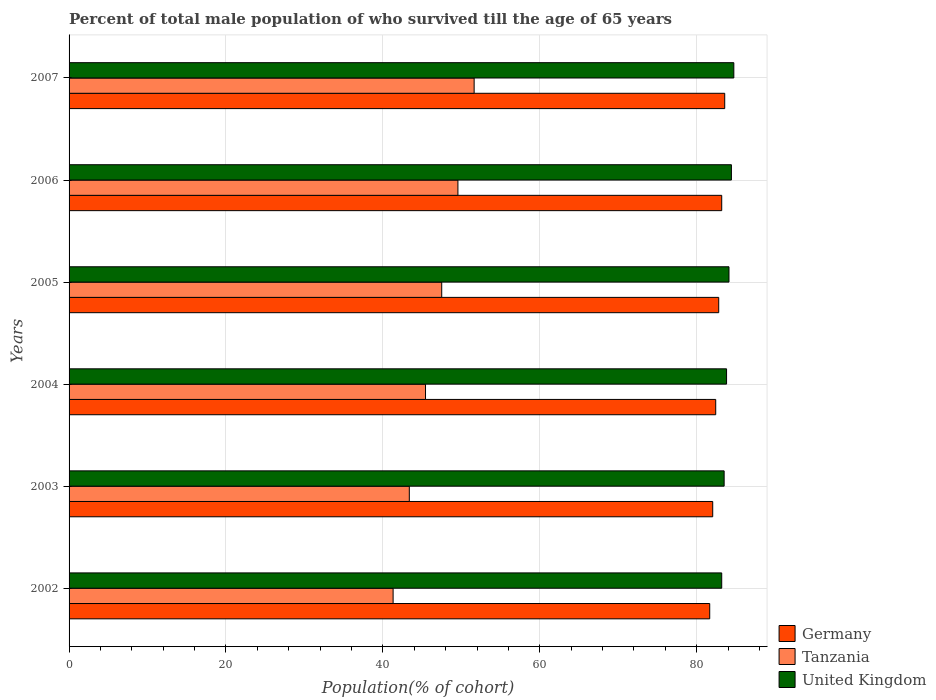Are the number of bars per tick equal to the number of legend labels?
Offer a very short reply. Yes. Are the number of bars on each tick of the Y-axis equal?
Make the answer very short. Yes. How many bars are there on the 1st tick from the top?
Provide a succinct answer. 3. In how many cases, is the number of bars for a given year not equal to the number of legend labels?
Ensure brevity in your answer.  0. What is the percentage of total male population who survived till the age of 65 years in Tanzania in 2006?
Give a very brief answer. 49.56. Across all years, what is the maximum percentage of total male population who survived till the age of 65 years in Germany?
Give a very brief answer. 83.57. Across all years, what is the minimum percentage of total male population who survived till the age of 65 years in Tanzania?
Offer a terse response. 41.3. In which year was the percentage of total male population who survived till the age of 65 years in Tanzania minimum?
Keep it short and to the point. 2002. What is the total percentage of total male population who survived till the age of 65 years in Tanzania in the graph?
Provide a short and direct response. 278.79. What is the difference between the percentage of total male population who survived till the age of 65 years in Germany in 2002 and that in 2006?
Your answer should be compact. -1.53. What is the difference between the percentage of total male population who survived till the age of 65 years in Germany in 2006 and the percentage of total male population who survived till the age of 65 years in United Kingdom in 2003?
Your answer should be very brief. -0.31. What is the average percentage of total male population who survived till the age of 65 years in Germany per year?
Make the answer very short. 82.61. In the year 2007, what is the difference between the percentage of total male population who survived till the age of 65 years in Tanzania and percentage of total male population who survived till the age of 65 years in United Kingdom?
Provide a succinct answer. -33.1. What is the ratio of the percentage of total male population who survived till the age of 65 years in Germany in 2004 to that in 2006?
Provide a short and direct response. 0.99. Is the percentage of total male population who survived till the age of 65 years in Germany in 2004 less than that in 2007?
Provide a succinct answer. Yes. What is the difference between the highest and the second highest percentage of total male population who survived till the age of 65 years in Germany?
Your answer should be very brief. 0.38. What is the difference between the highest and the lowest percentage of total male population who survived till the age of 65 years in Tanzania?
Ensure brevity in your answer.  10.33. In how many years, is the percentage of total male population who survived till the age of 65 years in Germany greater than the average percentage of total male population who survived till the age of 65 years in Germany taken over all years?
Keep it short and to the point. 3. Is the sum of the percentage of total male population who survived till the age of 65 years in United Kingdom in 2004 and 2007 greater than the maximum percentage of total male population who survived till the age of 65 years in Germany across all years?
Keep it short and to the point. Yes. What does the 2nd bar from the bottom in 2005 represents?
Your response must be concise. Tanzania. Is it the case that in every year, the sum of the percentage of total male population who survived till the age of 65 years in United Kingdom and percentage of total male population who survived till the age of 65 years in Germany is greater than the percentage of total male population who survived till the age of 65 years in Tanzania?
Ensure brevity in your answer.  Yes. Are all the bars in the graph horizontal?
Offer a terse response. Yes. What is the difference between two consecutive major ticks on the X-axis?
Offer a very short reply. 20. Does the graph contain grids?
Your answer should be compact. Yes. Where does the legend appear in the graph?
Offer a terse response. Bottom right. How many legend labels are there?
Offer a terse response. 3. What is the title of the graph?
Make the answer very short. Percent of total male population of who survived till the age of 65 years. Does "Suriname" appear as one of the legend labels in the graph?
Offer a terse response. No. What is the label or title of the X-axis?
Provide a short and direct response. Population(% of cohort). What is the label or title of the Y-axis?
Give a very brief answer. Years. What is the Population(% of cohort) in Germany in 2002?
Your response must be concise. 81.65. What is the Population(% of cohort) in Tanzania in 2002?
Your answer should be compact. 41.3. What is the Population(% of cohort) of United Kingdom in 2002?
Provide a succinct answer. 83.18. What is the Population(% of cohort) in Germany in 2003?
Provide a short and direct response. 82.04. What is the Population(% of cohort) of Tanzania in 2003?
Give a very brief answer. 43.37. What is the Population(% of cohort) of United Kingdom in 2003?
Keep it short and to the point. 83.49. What is the Population(% of cohort) of Germany in 2004?
Provide a succinct answer. 82.42. What is the Population(% of cohort) of Tanzania in 2004?
Provide a succinct answer. 45.43. What is the Population(% of cohort) of United Kingdom in 2004?
Offer a very short reply. 83.8. What is the Population(% of cohort) of Germany in 2005?
Your answer should be compact. 82.8. What is the Population(% of cohort) in Tanzania in 2005?
Offer a very short reply. 47.5. What is the Population(% of cohort) in United Kingdom in 2005?
Your answer should be compact. 84.11. What is the Population(% of cohort) of Germany in 2006?
Your response must be concise. 83.19. What is the Population(% of cohort) in Tanzania in 2006?
Ensure brevity in your answer.  49.56. What is the Population(% of cohort) of United Kingdom in 2006?
Your answer should be very brief. 84.42. What is the Population(% of cohort) of Germany in 2007?
Your answer should be very brief. 83.57. What is the Population(% of cohort) of Tanzania in 2007?
Provide a short and direct response. 51.63. What is the Population(% of cohort) of United Kingdom in 2007?
Your answer should be very brief. 84.73. Across all years, what is the maximum Population(% of cohort) of Germany?
Provide a succinct answer. 83.57. Across all years, what is the maximum Population(% of cohort) in Tanzania?
Provide a short and direct response. 51.63. Across all years, what is the maximum Population(% of cohort) in United Kingdom?
Your answer should be compact. 84.73. Across all years, what is the minimum Population(% of cohort) in Germany?
Ensure brevity in your answer.  81.65. Across all years, what is the minimum Population(% of cohort) in Tanzania?
Offer a terse response. 41.3. Across all years, what is the minimum Population(% of cohort) in United Kingdom?
Offer a very short reply. 83.18. What is the total Population(% of cohort) in Germany in the graph?
Your response must be concise. 495.67. What is the total Population(% of cohort) of Tanzania in the graph?
Your response must be concise. 278.79. What is the total Population(% of cohort) in United Kingdom in the graph?
Offer a terse response. 503.74. What is the difference between the Population(% of cohort) of Germany in 2002 and that in 2003?
Offer a very short reply. -0.38. What is the difference between the Population(% of cohort) of Tanzania in 2002 and that in 2003?
Provide a succinct answer. -2.07. What is the difference between the Population(% of cohort) of United Kingdom in 2002 and that in 2003?
Provide a succinct answer. -0.31. What is the difference between the Population(% of cohort) in Germany in 2002 and that in 2004?
Offer a very short reply. -0.77. What is the difference between the Population(% of cohort) of Tanzania in 2002 and that in 2004?
Make the answer very short. -4.13. What is the difference between the Population(% of cohort) in United Kingdom in 2002 and that in 2004?
Keep it short and to the point. -0.62. What is the difference between the Population(% of cohort) of Germany in 2002 and that in 2005?
Your response must be concise. -1.15. What is the difference between the Population(% of cohort) in Tanzania in 2002 and that in 2005?
Make the answer very short. -6.2. What is the difference between the Population(% of cohort) in United Kingdom in 2002 and that in 2005?
Your response must be concise. -0.93. What is the difference between the Population(% of cohort) in Germany in 2002 and that in 2006?
Offer a very short reply. -1.53. What is the difference between the Population(% of cohort) of Tanzania in 2002 and that in 2006?
Keep it short and to the point. -8.26. What is the difference between the Population(% of cohort) in United Kingdom in 2002 and that in 2006?
Your answer should be very brief. -1.24. What is the difference between the Population(% of cohort) of Germany in 2002 and that in 2007?
Ensure brevity in your answer.  -1.91. What is the difference between the Population(% of cohort) of Tanzania in 2002 and that in 2007?
Ensure brevity in your answer.  -10.33. What is the difference between the Population(% of cohort) in United Kingdom in 2002 and that in 2007?
Your answer should be compact. -1.54. What is the difference between the Population(% of cohort) of Germany in 2003 and that in 2004?
Offer a very short reply. -0.38. What is the difference between the Population(% of cohort) in Tanzania in 2003 and that in 2004?
Offer a very short reply. -2.07. What is the difference between the Population(% of cohort) of United Kingdom in 2003 and that in 2004?
Ensure brevity in your answer.  -0.31. What is the difference between the Population(% of cohort) of Germany in 2003 and that in 2005?
Your answer should be compact. -0.77. What is the difference between the Population(% of cohort) in Tanzania in 2003 and that in 2005?
Make the answer very short. -4.13. What is the difference between the Population(% of cohort) in United Kingdom in 2003 and that in 2005?
Your response must be concise. -0.62. What is the difference between the Population(% of cohort) of Germany in 2003 and that in 2006?
Give a very brief answer. -1.15. What is the difference between the Population(% of cohort) of Tanzania in 2003 and that in 2006?
Provide a succinct answer. -6.2. What is the difference between the Population(% of cohort) in United Kingdom in 2003 and that in 2006?
Keep it short and to the point. -0.93. What is the difference between the Population(% of cohort) in Germany in 2003 and that in 2007?
Your response must be concise. -1.53. What is the difference between the Population(% of cohort) of Tanzania in 2003 and that in 2007?
Offer a very short reply. -8.26. What is the difference between the Population(% of cohort) of United Kingdom in 2003 and that in 2007?
Provide a succinct answer. -1.24. What is the difference between the Population(% of cohort) in Germany in 2004 and that in 2005?
Your answer should be compact. -0.38. What is the difference between the Population(% of cohort) of Tanzania in 2004 and that in 2005?
Ensure brevity in your answer.  -2.07. What is the difference between the Population(% of cohort) in United Kingdom in 2004 and that in 2005?
Make the answer very short. -0.31. What is the difference between the Population(% of cohort) of Germany in 2004 and that in 2006?
Your answer should be very brief. -0.77. What is the difference between the Population(% of cohort) in Tanzania in 2004 and that in 2006?
Give a very brief answer. -4.13. What is the difference between the Population(% of cohort) of United Kingdom in 2004 and that in 2006?
Your answer should be compact. -0.62. What is the difference between the Population(% of cohort) of Germany in 2004 and that in 2007?
Make the answer very short. -1.15. What is the difference between the Population(% of cohort) in Tanzania in 2004 and that in 2007?
Make the answer very short. -6.2. What is the difference between the Population(% of cohort) of United Kingdom in 2004 and that in 2007?
Offer a very short reply. -0.93. What is the difference between the Population(% of cohort) of Germany in 2005 and that in 2006?
Provide a succinct answer. -0.38. What is the difference between the Population(% of cohort) of Tanzania in 2005 and that in 2006?
Your answer should be very brief. -2.07. What is the difference between the Population(% of cohort) of United Kingdom in 2005 and that in 2006?
Offer a terse response. -0.31. What is the difference between the Population(% of cohort) in Germany in 2005 and that in 2007?
Your response must be concise. -0.77. What is the difference between the Population(% of cohort) in Tanzania in 2005 and that in 2007?
Ensure brevity in your answer.  -4.13. What is the difference between the Population(% of cohort) in United Kingdom in 2005 and that in 2007?
Offer a terse response. -0.62. What is the difference between the Population(% of cohort) in Germany in 2006 and that in 2007?
Ensure brevity in your answer.  -0.38. What is the difference between the Population(% of cohort) of Tanzania in 2006 and that in 2007?
Ensure brevity in your answer.  -2.07. What is the difference between the Population(% of cohort) in United Kingdom in 2006 and that in 2007?
Your answer should be very brief. -0.31. What is the difference between the Population(% of cohort) of Germany in 2002 and the Population(% of cohort) of Tanzania in 2003?
Keep it short and to the point. 38.29. What is the difference between the Population(% of cohort) of Germany in 2002 and the Population(% of cohort) of United Kingdom in 2003?
Your response must be concise. -1.84. What is the difference between the Population(% of cohort) of Tanzania in 2002 and the Population(% of cohort) of United Kingdom in 2003?
Provide a succinct answer. -42.19. What is the difference between the Population(% of cohort) in Germany in 2002 and the Population(% of cohort) in Tanzania in 2004?
Make the answer very short. 36.22. What is the difference between the Population(% of cohort) in Germany in 2002 and the Population(% of cohort) in United Kingdom in 2004?
Offer a very short reply. -2.15. What is the difference between the Population(% of cohort) of Tanzania in 2002 and the Population(% of cohort) of United Kingdom in 2004?
Make the answer very short. -42.5. What is the difference between the Population(% of cohort) of Germany in 2002 and the Population(% of cohort) of Tanzania in 2005?
Keep it short and to the point. 34.16. What is the difference between the Population(% of cohort) in Germany in 2002 and the Population(% of cohort) in United Kingdom in 2005?
Your answer should be compact. -2.46. What is the difference between the Population(% of cohort) of Tanzania in 2002 and the Population(% of cohort) of United Kingdom in 2005?
Give a very brief answer. -42.81. What is the difference between the Population(% of cohort) in Germany in 2002 and the Population(% of cohort) in Tanzania in 2006?
Your answer should be compact. 32.09. What is the difference between the Population(% of cohort) of Germany in 2002 and the Population(% of cohort) of United Kingdom in 2006?
Provide a succinct answer. -2.77. What is the difference between the Population(% of cohort) of Tanzania in 2002 and the Population(% of cohort) of United Kingdom in 2006?
Make the answer very short. -43.12. What is the difference between the Population(% of cohort) in Germany in 2002 and the Population(% of cohort) in Tanzania in 2007?
Make the answer very short. 30.03. What is the difference between the Population(% of cohort) in Germany in 2002 and the Population(% of cohort) in United Kingdom in 2007?
Provide a short and direct response. -3.07. What is the difference between the Population(% of cohort) in Tanzania in 2002 and the Population(% of cohort) in United Kingdom in 2007?
Your response must be concise. -43.43. What is the difference between the Population(% of cohort) of Germany in 2003 and the Population(% of cohort) of Tanzania in 2004?
Ensure brevity in your answer.  36.61. What is the difference between the Population(% of cohort) in Germany in 2003 and the Population(% of cohort) in United Kingdom in 2004?
Provide a short and direct response. -1.76. What is the difference between the Population(% of cohort) in Tanzania in 2003 and the Population(% of cohort) in United Kingdom in 2004?
Your answer should be very brief. -40.44. What is the difference between the Population(% of cohort) in Germany in 2003 and the Population(% of cohort) in Tanzania in 2005?
Give a very brief answer. 34.54. What is the difference between the Population(% of cohort) of Germany in 2003 and the Population(% of cohort) of United Kingdom in 2005?
Make the answer very short. -2.07. What is the difference between the Population(% of cohort) in Tanzania in 2003 and the Population(% of cohort) in United Kingdom in 2005?
Offer a very short reply. -40.74. What is the difference between the Population(% of cohort) in Germany in 2003 and the Population(% of cohort) in Tanzania in 2006?
Your answer should be compact. 32.47. What is the difference between the Population(% of cohort) in Germany in 2003 and the Population(% of cohort) in United Kingdom in 2006?
Keep it short and to the point. -2.38. What is the difference between the Population(% of cohort) in Tanzania in 2003 and the Population(% of cohort) in United Kingdom in 2006?
Offer a very short reply. -41.05. What is the difference between the Population(% of cohort) of Germany in 2003 and the Population(% of cohort) of Tanzania in 2007?
Offer a terse response. 30.41. What is the difference between the Population(% of cohort) of Germany in 2003 and the Population(% of cohort) of United Kingdom in 2007?
Your response must be concise. -2.69. What is the difference between the Population(% of cohort) in Tanzania in 2003 and the Population(% of cohort) in United Kingdom in 2007?
Make the answer very short. -41.36. What is the difference between the Population(% of cohort) of Germany in 2004 and the Population(% of cohort) of Tanzania in 2005?
Your answer should be very brief. 34.92. What is the difference between the Population(% of cohort) in Germany in 2004 and the Population(% of cohort) in United Kingdom in 2005?
Ensure brevity in your answer.  -1.69. What is the difference between the Population(% of cohort) of Tanzania in 2004 and the Population(% of cohort) of United Kingdom in 2005?
Your answer should be very brief. -38.68. What is the difference between the Population(% of cohort) in Germany in 2004 and the Population(% of cohort) in Tanzania in 2006?
Keep it short and to the point. 32.86. What is the difference between the Population(% of cohort) of Germany in 2004 and the Population(% of cohort) of United Kingdom in 2006?
Ensure brevity in your answer.  -2. What is the difference between the Population(% of cohort) in Tanzania in 2004 and the Population(% of cohort) in United Kingdom in 2006?
Provide a succinct answer. -38.99. What is the difference between the Population(% of cohort) of Germany in 2004 and the Population(% of cohort) of Tanzania in 2007?
Make the answer very short. 30.79. What is the difference between the Population(% of cohort) of Germany in 2004 and the Population(% of cohort) of United Kingdom in 2007?
Offer a terse response. -2.31. What is the difference between the Population(% of cohort) of Tanzania in 2004 and the Population(% of cohort) of United Kingdom in 2007?
Offer a terse response. -39.3. What is the difference between the Population(% of cohort) in Germany in 2005 and the Population(% of cohort) in Tanzania in 2006?
Your response must be concise. 33.24. What is the difference between the Population(% of cohort) of Germany in 2005 and the Population(% of cohort) of United Kingdom in 2006?
Provide a succinct answer. -1.62. What is the difference between the Population(% of cohort) in Tanzania in 2005 and the Population(% of cohort) in United Kingdom in 2006?
Your answer should be compact. -36.92. What is the difference between the Population(% of cohort) in Germany in 2005 and the Population(% of cohort) in Tanzania in 2007?
Keep it short and to the point. 31.17. What is the difference between the Population(% of cohort) in Germany in 2005 and the Population(% of cohort) in United Kingdom in 2007?
Give a very brief answer. -1.93. What is the difference between the Population(% of cohort) of Tanzania in 2005 and the Population(% of cohort) of United Kingdom in 2007?
Make the answer very short. -37.23. What is the difference between the Population(% of cohort) in Germany in 2006 and the Population(% of cohort) in Tanzania in 2007?
Provide a short and direct response. 31.56. What is the difference between the Population(% of cohort) of Germany in 2006 and the Population(% of cohort) of United Kingdom in 2007?
Your answer should be very brief. -1.54. What is the difference between the Population(% of cohort) of Tanzania in 2006 and the Population(% of cohort) of United Kingdom in 2007?
Offer a terse response. -35.17. What is the average Population(% of cohort) of Germany per year?
Provide a succinct answer. 82.61. What is the average Population(% of cohort) in Tanzania per year?
Provide a short and direct response. 46.46. What is the average Population(% of cohort) in United Kingdom per year?
Keep it short and to the point. 83.96. In the year 2002, what is the difference between the Population(% of cohort) in Germany and Population(% of cohort) in Tanzania?
Make the answer very short. 40.35. In the year 2002, what is the difference between the Population(% of cohort) in Germany and Population(% of cohort) in United Kingdom?
Make the answer very short. -1.53. In the year 2002, what is the difference between the Population(% of cohort) of Tanzania and Population(% of cohort) of United Kingdom?
Your answer should be compact. -41.88. In the year 2003, what is the difference between the Population(% of cohort) in Germany and Population(% of cohort) in Tanzania?
Offer a terse response. 38.67. In the year 2003, what is the difference between the Population(% of cohort) of Germany and Population(% of cohort) of United Kingdom?
Your answer should be compact. -1.46. In the year 2003, what is the difference between the Population(% of cohort) of Tanzania and Population(% of cohort) of United Kingdom?
Give a very brief answer. -40.13. In the year 2004, what is the difference between the Population(% of cohort) of Germany and Population(% of cohort) of Tanzania?
Give a very brief answer. 36.99. In the year 2004, what is the difference between the Population(% of cohort) in Germany and Population(% of cohort) in United Kingdom?
Provide a succinct answer. -1.38. In the year 2004, what is the difference between the Population(% of cohort) of Tanzania and Population(% of cohort) of United Kingdom?
Provide a succinct answer. -38.37. In the year 2005, what is the difference between the Population(% of cohort) in Germany and Population(% of cohort) in Tanzania?
Offer a very short reply. 35.3. In the year 2005, what is the difference between the Population(% of cohort) in Germany and Population(% of cohort) in United Kingdom?
Provide a succinct answer. -1.31. In the year 2005, what is the difference between the Population(% of cohort) of Tanzania and Population(% of cohort) of United Kingdom?
Give a very brief answer. -36.61. In the year 2006, what is the difference between the Population(% of cohort) of Germany and Population(% of cohort) of Tanzania?
Ensure brevity in your answer.  33.62. In the year 2006, what is the difference between the Population(% of cohort) of Germany and Population(% of cohort) of United Kingdom?
Make the answer very short. -1.24. In the year 2006, what is the difference between the Population(% of cohort) in Tanzania and Population(% of cohort) in United Kingdom?
Offer a very short reply. -34.86. In the year 2007, what is the difference between the Population(% of cohort) of Germany and Population(% of cohort) of Tanzania?
Ensure brevity in your answer.  31.94. In the year 2007, what is the difference between the Population(% of cohort) in Germany and Population(% of cohort) in United Kingdom?
Offer a very short reply. -1.16. In the year 2007, what is the difference between the Population(% of cohort) in Tanzania and Population(% of cohort) in United Kingdom?
Offer a terse response. -33.1. What is the ratio of the Population(% of cohort) in Tanzania in 2002 to that in 2003?
Provide a succinct answer. 0.95. What is the ratio of the Population(% of cohort) of United Kingdom in 2002 to that in 2003?
Give a very brief answer. 1. What is the ratio of the Population(% of cohort) of Germany in 2002 to that in 2004?
Your response must be concise. 0.99. What is the ratio of the Population(% of cohort) in Tanzania in 2002 to that in 2004?
Offer a terse response. 0.91. What is the ratio of the Population(% of cohort) of United Kingdom in 2002 to that in 2004?
Provide a succinct answer. 0.99. What is the ratio of the Population(% of cohort) of Germany in 2002 to that in 2005?
Your response must be concise. 0.99. What is the ratio of the Population(% of cohort) of Tanzania in 2002 to that in 2005?
Provide a short and direct response. 0.87. What is the ratio of the Population(% of cohort) of United Kingdom in 2002 to that in 2005?
Offer a very short reply. 0.99. What is the ratio of the Population(% of cohort) of Germany in 2002 to that in 2006?
Provide a short and direct response. 0.98. What is the ratio of the Population(% of cohort) of United Kingdom in 2002 to that in 2006?
Make the answer very short. 0.99. What is the ratio of the Population(% of cohort) in Germany in 2002 to that in 2007?
Your response must be concise. 0.98. What is the ratio of the Population(% of cohort) of United Kingdom in 2002 to that in 2007?
Your answer should be very brief. 0.98. What is the ratio of the Population(% of cohort) of Germany in 2003 to that in 2004?
Keep it short and to the point. 1. What is the ratio of the Population(% of cohort) of Tanzania in 2003 to that in 2004?
Ensure brevity in your answer.  0.95. What is the ratio of the Population(% of cohort) in United Kingdom in 2003 to that in 2005?
Ensure brevity in your answer.  0.99. What is the ratio of the Population(% of cohort) in Germany in 2003 to that in 2006?
Make the answer very short. 0.99. What is the ratio of the Population(% of cohort) of Germany in 2003 to that in 2007?
Provide a succinct answer. 0.98. What is the ratio of the Population(% of cohort) in Tanzania in 2003 to that in 2007?
Give a very brief answer. 0.84. What is the ratio of the Population(% of cohort) of United Kingdom in 2003 to that in 2007?
Keep it short and to the point. 0.99. What is the ratio of the Population(% of cohort) of Tanzania in 2004 to that in 2005?
Provide a succinct answer. 0.96. What is the ratio of the Population(% of cohort) in United Kingdom in 2004 to that in 2005?
Ensure brevity in your answer.  1. What is the ratio of the Population(% of cohort) in Germany in 2004 to that in 2006?
Offer a terse response. 0.99. What is the ratio of the Population(% of cohort) in Tanzania in 2004 to that in 2006?
Give a very brief answer. 0.92. What is the ratio of the Population(% of cohort) of United Kingdom in 2004 to that in 2006?
Offer a very short reply. 0.99. What is the ratio of the Population(% of cohort) of Germany in 2004 to that in 2007?
Offer a terse response. 0.99. What is the ratio of the Population(% of cohort) in United Kingdom in 2004 to that in 2007?
Give a very brief answer. 0.99. What is the ratio of the Population(% of cohort) in Tanzania in 2005 to that in 2006?
Make the answer very short. 0.96. What is the ratio of the Population(% of cohort) in United Kingdom in 2005 to that in 2007?
Your answer should be compact. 0.99. What is the ratio of the Population(% of cohort) in Germany in 2006 to that in 2007?
Keep it short and to the point. 1. What is the difference between the highest and the second highest Population(% of cohort) in Germany?
Your answer should be very brief. 0.38. What is the difference between the highest and the second highest Population(% of cohort) of Tanzania?
Give a very brief answer. 2.07. What is the difference between the highest and the second highest Population(% of cohort) in United Kingdom?
Offer a terse response. 0.31. What is the difference between the highest and the lowest Population(% of cohort) in Germany?
Your answer should be compact. 1.91. What is the difference between the highest and the lowest Population(% of cohort) of Tanzania?
Ensure brevity in your answer.  10.33. What is the difference between the highest and the lowest Population(% of cohort) in United Kingdom?
Your answer should be very brief. 1.54. 